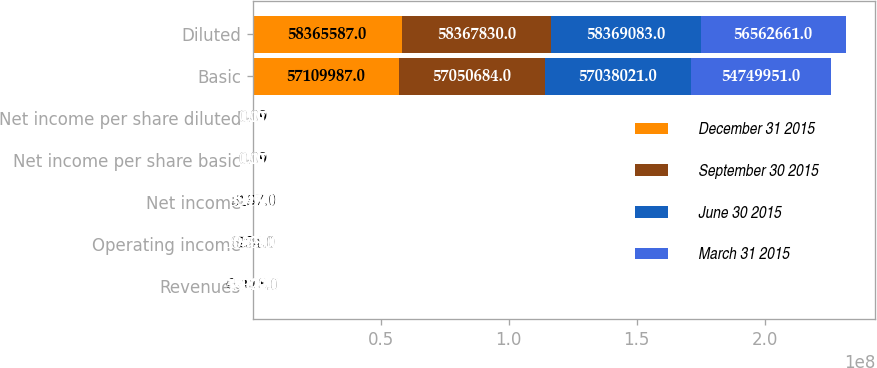Convert chart to OTSL. <chart><loc_0><loc_0><loc_500><loc_500><stacked_bar_chart><ecel><fcel>Revenues<fcel>Operating income<fcel>Net income<fcel>Net income per share basic<fcel>Net income per share diluted<fcel>Basic<fcel>Diluted<nl><fcel>December 31 2015<fcel>65118<fcel>6234<fcel>5157<fcel>0.09<fcel>0.09<fcel>5.711e+07<fcel>5.83656e+07<nl><fcel>September 30 2015<fcel>55340<fcel>6855<fcel>3847<fcel>0.07<fcel>0.07<fcel>5.70507e+07<fcel>5.83678e+07<nl><fcel>June 30 2015<fcel>48973<fcel>10808<fcel>5946<fcel>0.1<fcel>0.1<fcel>5.7038e+07<fcel>5.83691e+07<nl><fcel>March 31 2015<fcel>55222<fcel>10538<fcel>5995<fcel>0.11<fcel>0.11<fcel>5.475e+07<fcel>5.65627e+07<nl></chart> 